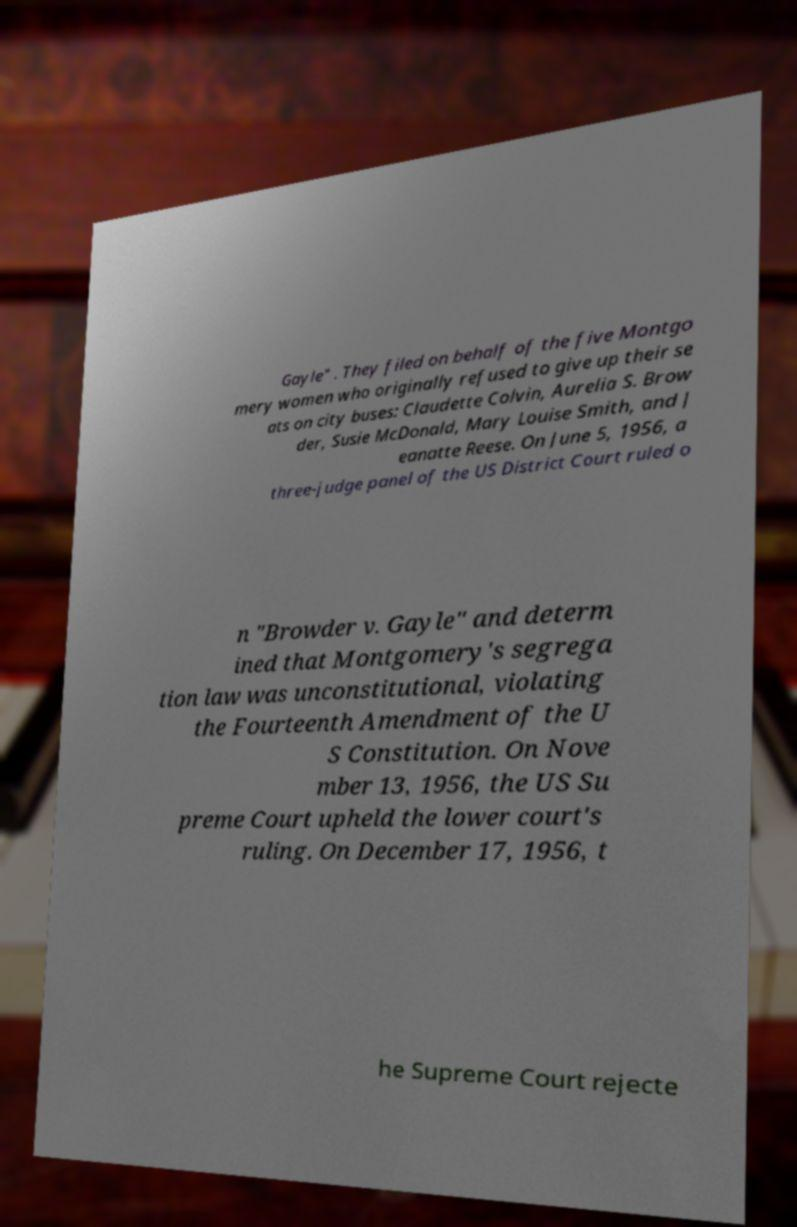Can you accurately transcribe the text from the provided image for me? Gayle" . They filed on behalf of the five Montgo mery women who originally refused to give up their se ats on city buses: Claudette Colvin, Aurelia S. Brow der, Susie McDonald, Mary Louise Smith, and J eanatte Reese. On June 5, 1956, a three-judge panel of the US District Court ruled o n "Browder v. Gayle" and determ ined that Montgomery's segrega tion law was unconstitutional, violating the Fourteenth Amendment of the U S Constitution. On Nove mber 13, 1956, the US Su preme Court upheld the lower court's ruling. On December 17, 1956, t he Supreme Court rejecte 